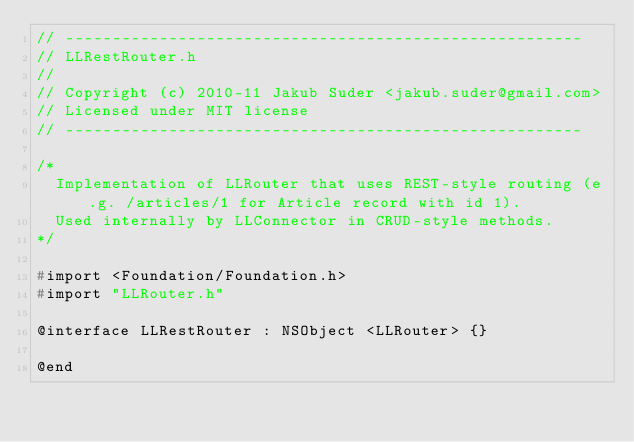<code> <loc_0><loc_0><loc_500><loc_500><_C_>// -------------------------------------------------------
// LLRestRouter.h
//
// Copyright (c) 2010-11 Jakub Suder <jakub.suder@gmail.com>
// Licensed under MIT license
// -------------------------------------------------------

/*
  Implementation of LLRouter that uses REST-style routing (e.g. /articles/1 for Article record with id 1).
  Used internally by LLConnector in CRUD-style methods.
*/

#import <Foundation/Foundation.h>
#import "LLRouter.h"

@interface LLRestRouter : NSObject <LLRouter> {}

@end
</code> 